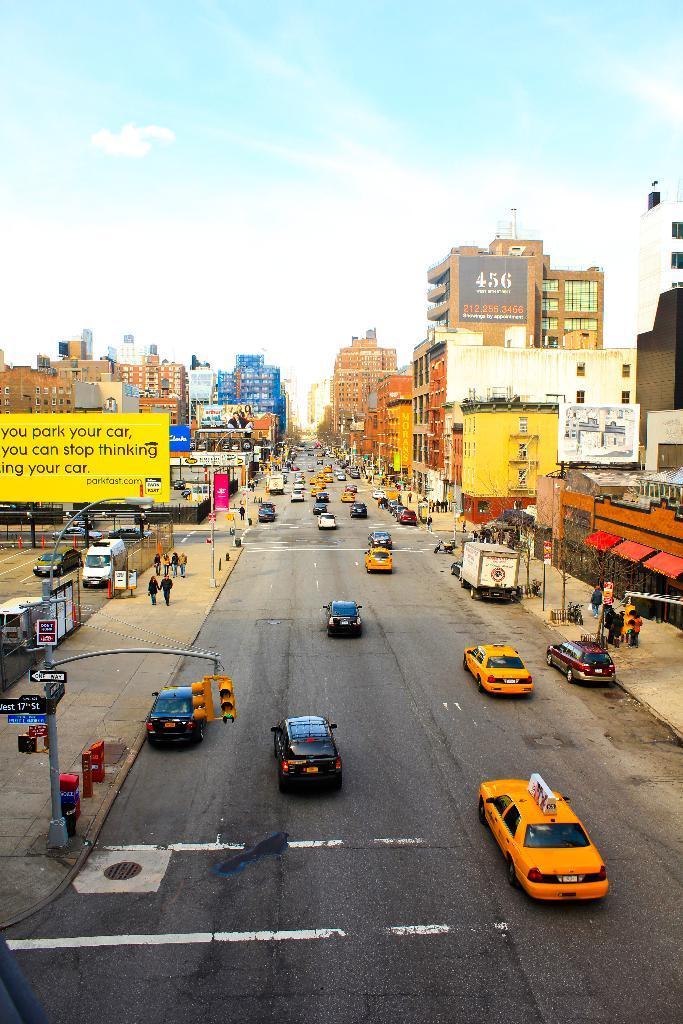Could you give a brief overview of what you see in this image? This image is clicked from the top view. In the center there is a road. There are vehicles moving on the road. Beside the road there is a walkway. There are street light poles, traffic signal poles, sign board poles and a few people walking on the walkway. On the either sides of the image there are buildings. To the left there is a hoarding. There is text on the on the hoarding. At the top there is the sky. 